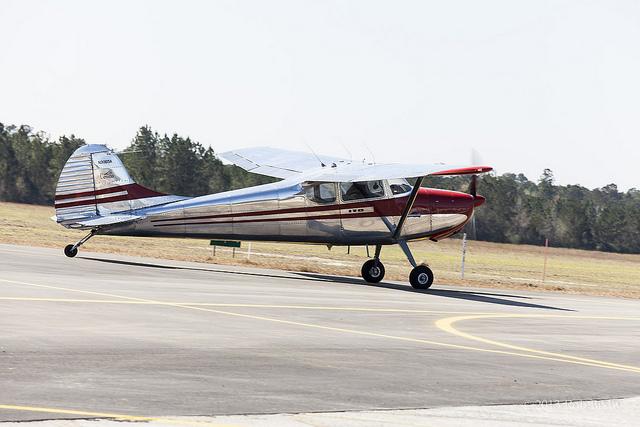How many wheels on the plane?
Answer briefly. 3. How many parts are red?
Quick response, please. 3. Is this a commercial airliner?
Give a very brief answer. No. What is in the picture?
Quick response, please. Plane. 